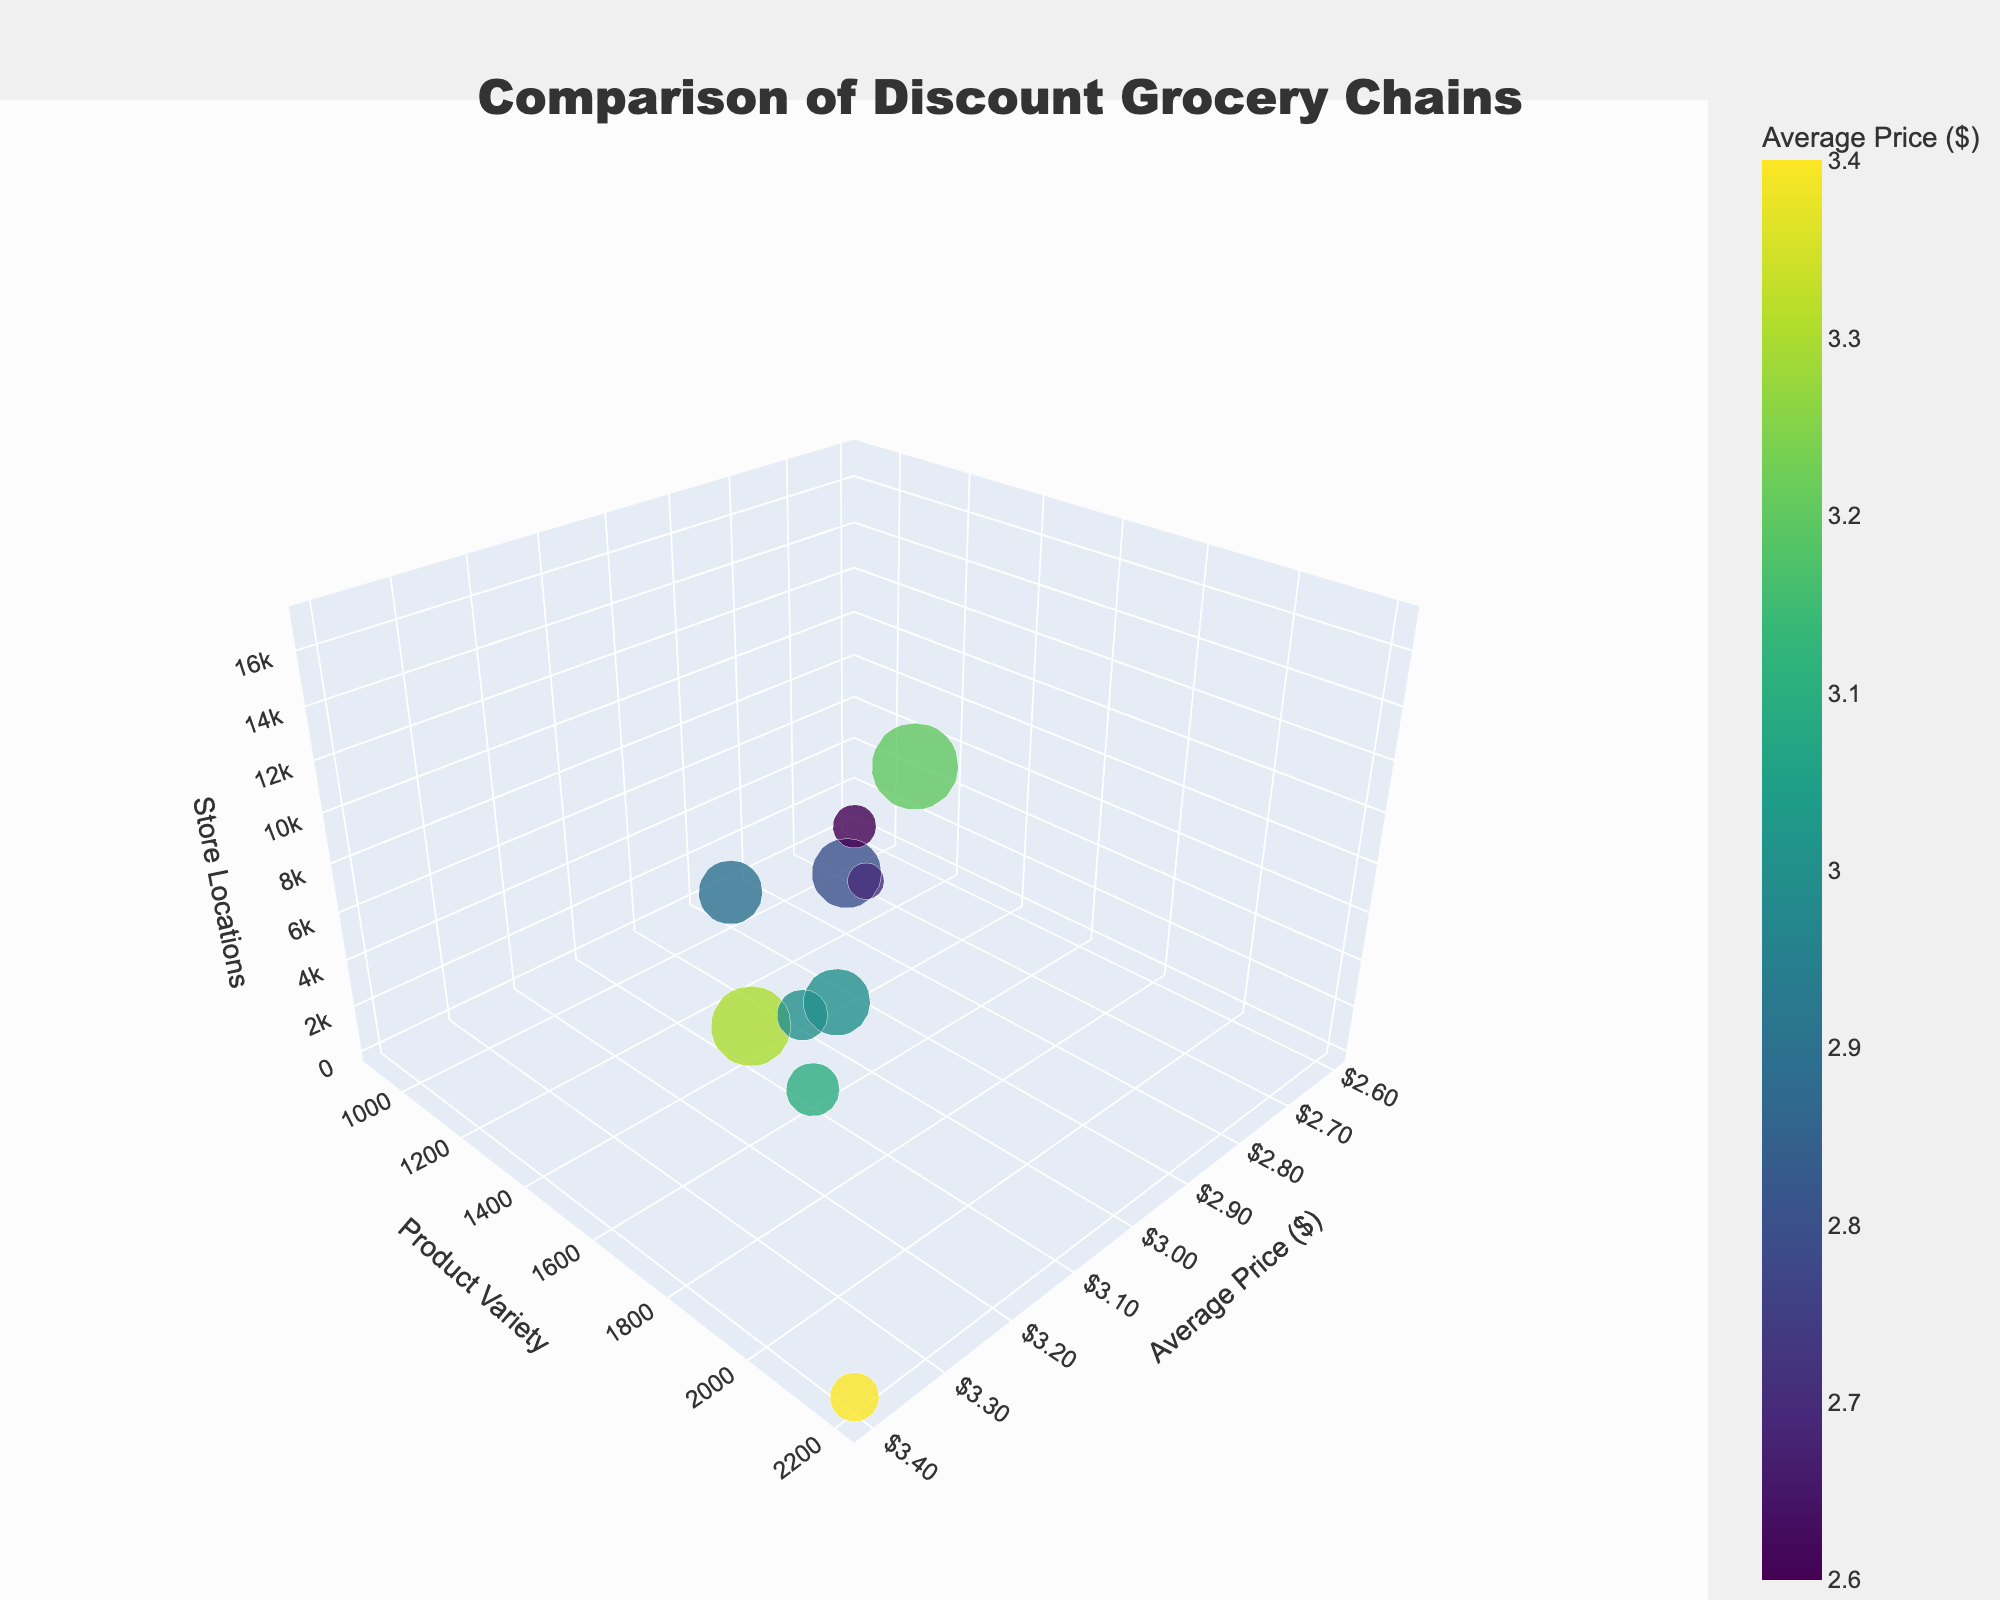What's the title of the figure? The title is located at the very top of the figure, often in bold and larger font. In this case, it reads 'Comparison of Discount Grocery Chains'.
Answer: Comparison of Discount Grocery Chains What is the range of average prices shown in the figure? By looking at the x-axis labeled 'Average Price ($)', we can see the range of values. The lowest price is $2.6, and the highest price is $3.4.
Answer: $2.6 to $3.4 Which chain has the largest bubble? The bubble size is determined by the number of store locations. The legend shows Dollar General with the highest store locations, making its bubble the largest.
Answer: Dollar General Which chain has the smallest average price? By observing the x-axis, we look for the leftmost bubble, which represents the lowest average price. WinCo Foods is that chain with an average price of $2.6.
Answer: WinCo Foods How many chains have a product variety of more than 1,500 items? Product variety is shown on the y-axis. By examining the bubbles above the 1,500 mark, we count five chains: Lidl, Dollar General, Family Dollar, Grocery Outlet, and Smart & Final.
Answer: Five Which chain offers the highest product variety and at what average price? By finding the highest point on the y-axis (Product Variety), we see that Smart & Final has the highest variety of 2,200 items with an average price of $3.4.
Answer: Smart & Final, $3.4 Compare the store locations of Family Dollar and Save A Lot. Family Dollar and Save A Lot are described by their bubbles. Family Dollar is much larger than Save A Lot. Checking their labels shows Family Dollar has 8,000 locations, and Save A Lot has 1,300.
Answer: Family Dollar: 8,000, Save A Lot: 1,300 Which chain has the lowest product variety and how many store locations does it have? We look for the lowest point on the y-axis which shows store locations below the axis. WinCo Foods appears as the chain with 900 product varieties and 130 store locations.
Answer: WinCo Foods, 130 What is the color range of the bubbles and what does it represent? The colors range from one end of the Viridis colorscale to the other, representing values from cold (purple) to warm (yellow) hues, specifically average price.
Answer: Viridis colorscale representing Average Price Which bubble is closest to the average values for all three axes? Checking the middle point on the axes, Price Rite seems close to the average ($2.7, 1,100 varieties, and 60 locations). It shows Price Rite is near the center across average prices, product variety, and store locations.
Answer: Price Rite 